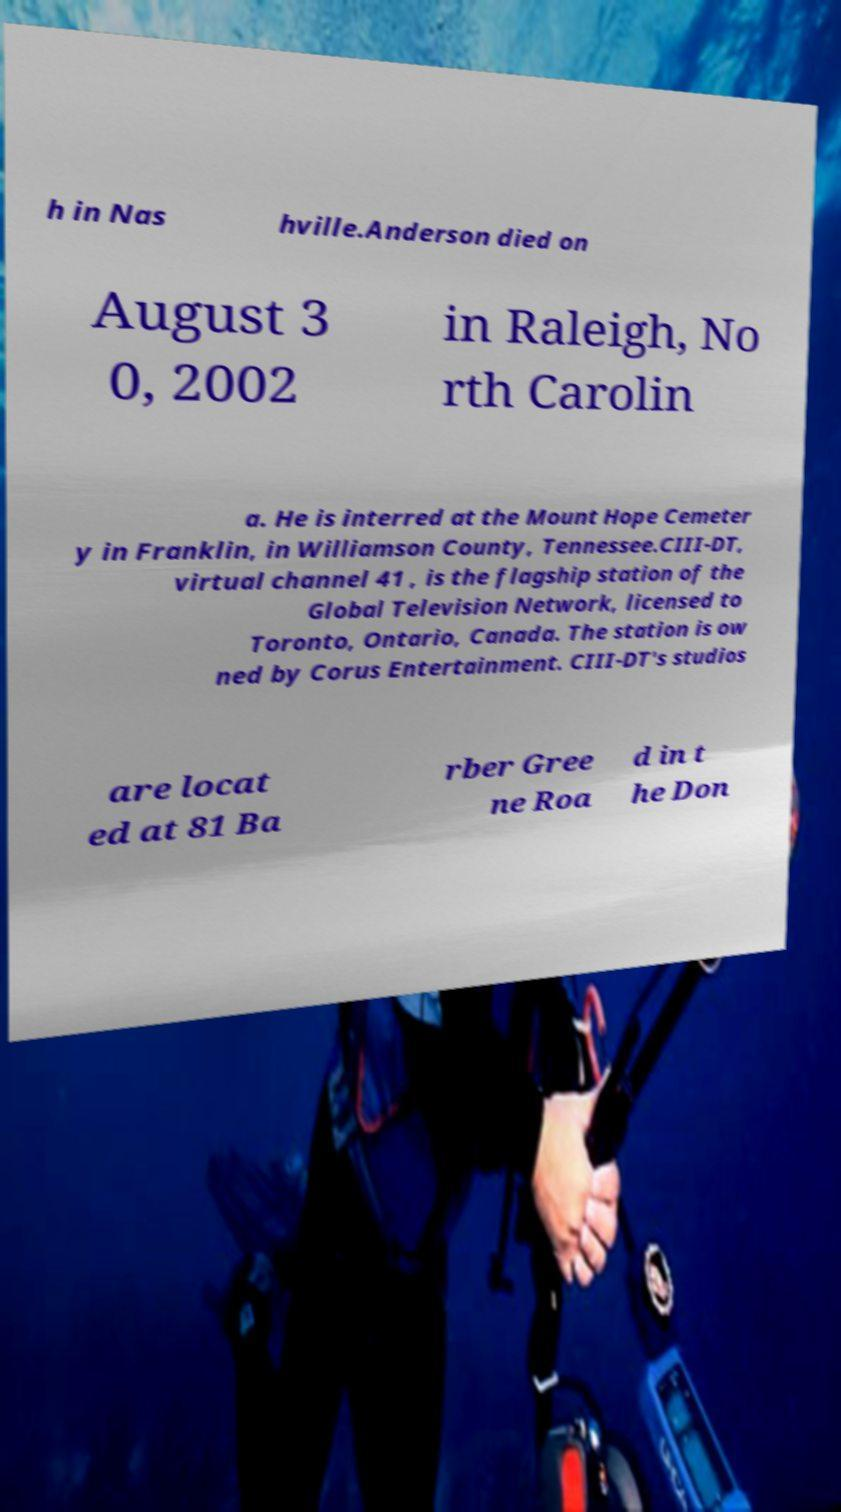Can you accurately transcribe the text from the provided image for me? h in Nas hville.Anderson died on August 3 0, 2002 in Raleigh, No rth Carolin a. He is interred at the Mount Hope Cemeter y in Franklin, in Williamson County, Tennessee.CIII-DT, virtual channel 41 , is the flagship station of the Global Television Network, licensed to Toronto, Ontario, Canada. The station is ow ned by Corus Entertainment. CIII-DT's studios are locat ed at 81 Ba rber Gree ne Roa d in t he Don 